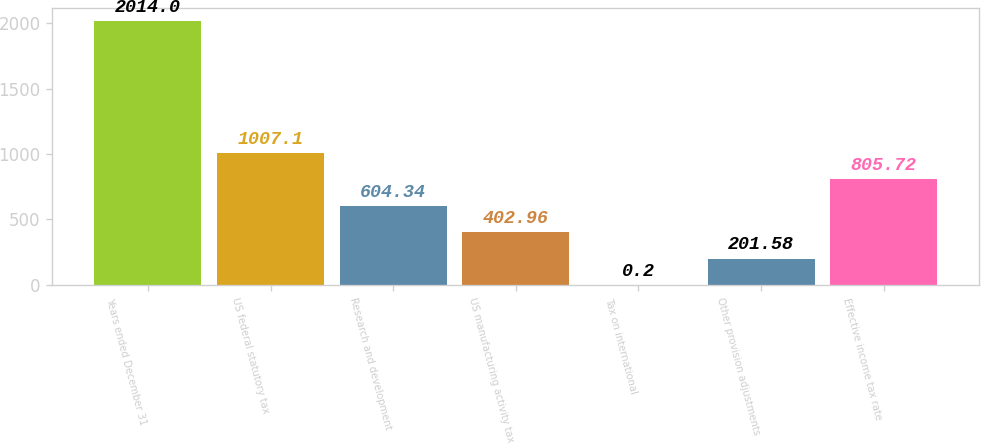<chart> <loc_0><loc_0><loc_500><loc_500><bar_chart><fcel>Years ended December 31<fcel>US federal statutory tax<fcel>Research and development<fcel>US manufacturing activity tax<fcel>Tax on international<fcel>Other provision adjustments<fcel>Effective income tax rate<nl><fcel>2014<fcel>1007.1<fcel>604.34<fcel>402.96<fcel>0.2<fcel>201.58<fcel>805.72<nl></chart> 